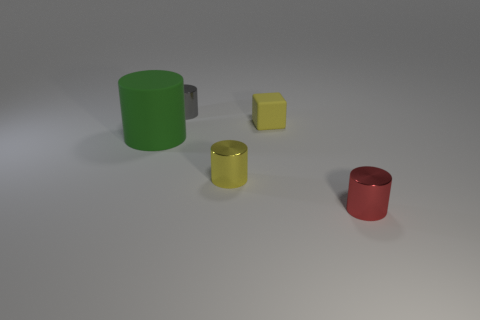Subtract all yellow metallic cylinders. How many cylinders are left? 3 Add 4 yellow rubber cubes. How many objects exist? 9 Subtract all green cylinders. How many cylinders are left? 3 Subtract 1 cylinders. How many cylinders are left? 3 Subtract all blocks. How many objects are left? 4 Add 4 large objects. How many large objects exist? 5 Subtract 0 green spheres. How many objects are left? 5 Subtract all cyan cylinders. Subtract all yellow spheres. How many cylinders are left? 4 Subtract all large purple shiny cylinders. Subtract all red things. How many objects are left? 4 Add 3 green objects. How many green objects are left? 4 